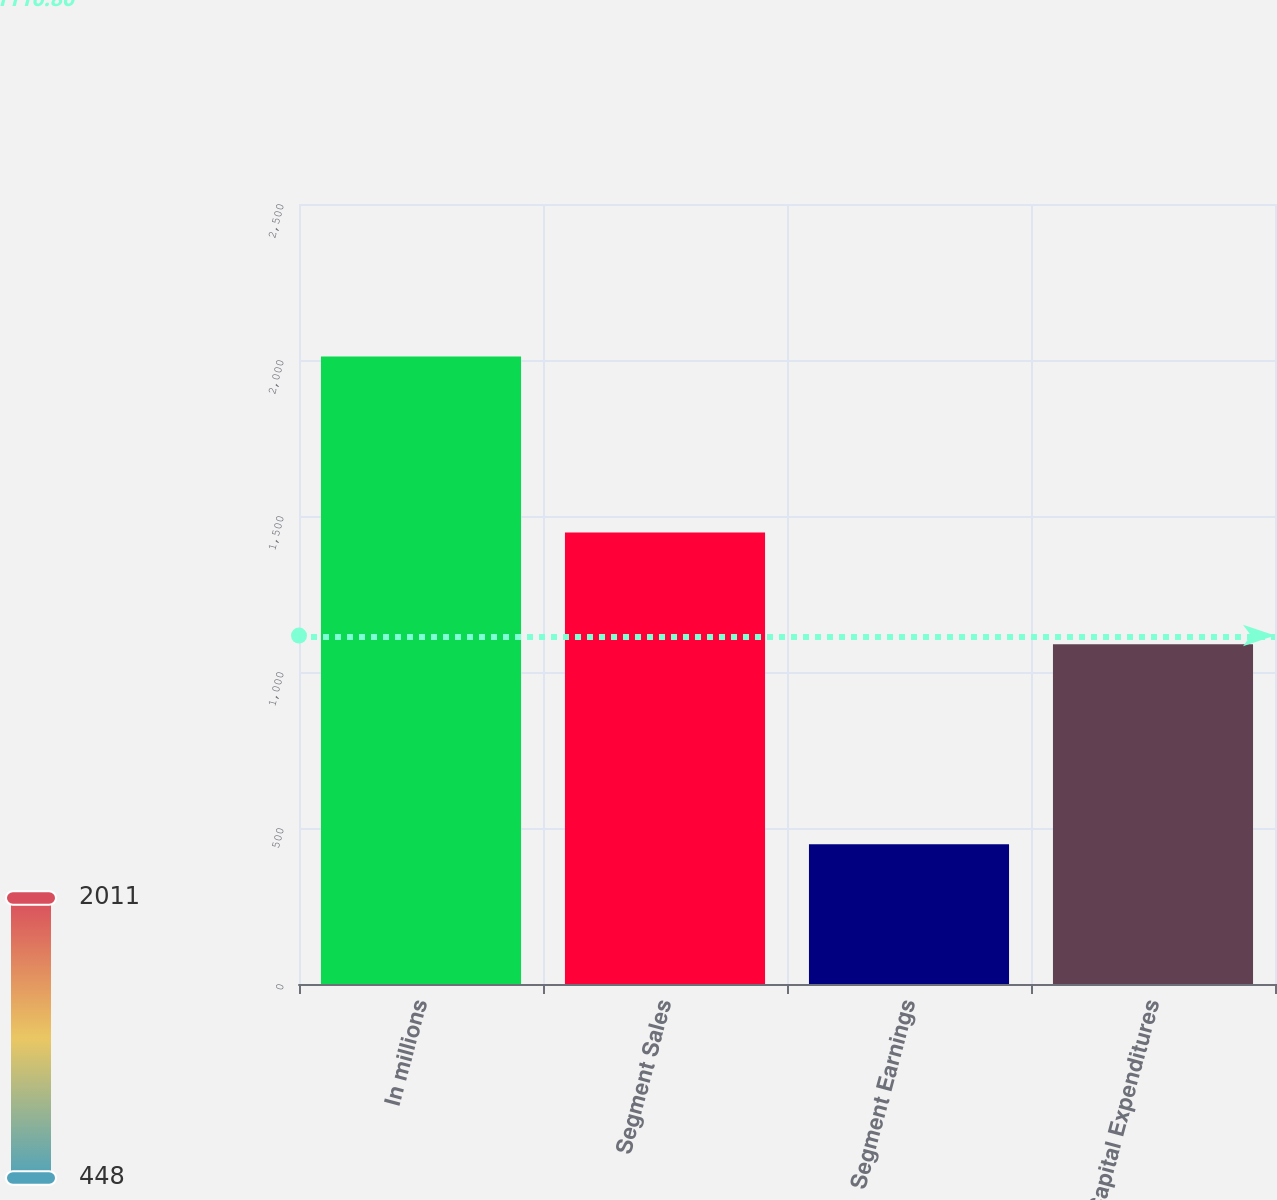Convert chart. <chart><loc_0><loc_0><loc_500><loc_500><bar_chart><fcel>In millions<fcel>Segment Sales<fcel>Segment Earnings<fcel>Capital Expenditures<nl><fcel>2011<fcel>1447<fcel>448<fcel>1089<nl></chart> 